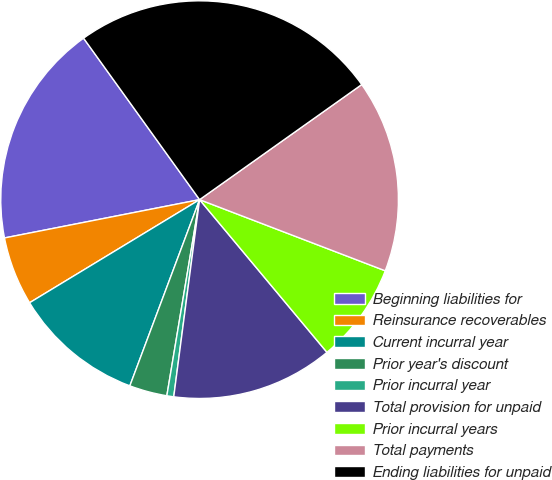Convert chart to OTSL. <chart><loc_0><loc_0><loc_500><loc_500><pie_chart><fcel>Beginning liabilities for<fcel>Reinsurance recoverables<fcel>Current incurral year<fcel>Prior year's discount<fcel>Prior incurral year<fcel>Total provision for unpaid<fcel>Prior incurral years<fcel>Total payments<fcel>Ending liabilities for unpaid<nl><fcel>18.17%<fcel>5.59%<fcel>10.62%<fcel>3.07%<fcel>0.56%<fcel>13.14%<fcel>8.11%<fcel>15.65%<fcel>25.09%<nl></chart> 